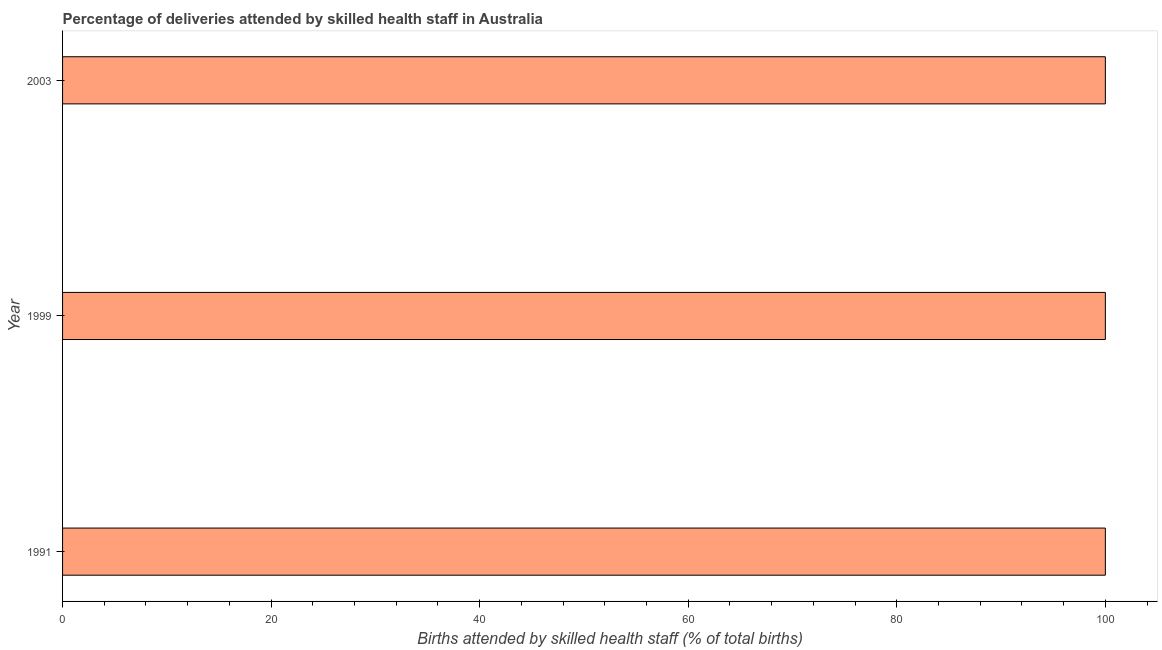What is the title of the graph?
Provide a short and direct response. Percentage of deliveries attended by skilled health staff in Australia. What is the label or title of the X-axis?
Offer a very short reply. Births attended by skilled health staff (% of total births). Across all years, what is the maximum number of births attended by skilled health staff?
Offer a terse response. 100. Across all years, what is the minimum number of births attended by skilled health staff?
Ensure brevity in your answer.  100. In which year was the number of births attended by skilled health staff maximum?
Your answer should be very brief. 1991. In which year was the number of births attended by skilled health staff minimum?
Your answer should be compact. 1991. What is the sum of the number of births attended by skilled health staff?
Your answer should be very brief. 300. What is the ratio of the number of births attended by skilled health staff in 1991 to that in 2003?
Your answer should be very brief. 1. Is the number of births attended by skilled health staff in 1999 less than that in 2003?
Offer a terse response. No. Is the difference between the number of births attended by skilled health staff in 1991 and 1999 greater than the difference between any two years?
Your response must be concise. Yes. What is the difference between the highest and the second highest number of births attended by skilled health staff?
Make the answer very short. 0. In how many years, is the number of births attended by skilled health staff greater than the average number of births attended by skilled health staff taken over all years?
Your response must be concise. 0. Are all the bars in the graph horizontal?
Provide a short and direct response. Yes. How many years are there in the graph?
Provide a short and direct response. 3. What is the difference between two consecutive major ticks on the X-axis?
Provide a short and direct response. 20. Are the values on the major ticks of X-axis written in scientific E-notation?
Provide a succinct answer. No. What is the Births attended by skilled health staff (% of total births) in 1999?
Keep it short and to the point. 100. What is the Births attended by skilled health staff (% of total births) of 2003?
Give a very brief answer. 100. What is the difference between the Births attended by skilled health staff (% of total births) in 1991 and 2003?
Provide a short and direct response. 0. What is the difference between the Births attended by skilled health staff (% of total births) in 1999 and 2003?
Provide a short and direct response. 0. What is the ratio of the Births attended by skilled health staff (% of total births) in 1991 to that in 2003?
Offer a terse response. 1. What is the ratio of the Births attended by skilled health staff (% of total births) in 1999 to that in 2003?
Your answer should be very brief. 1. 